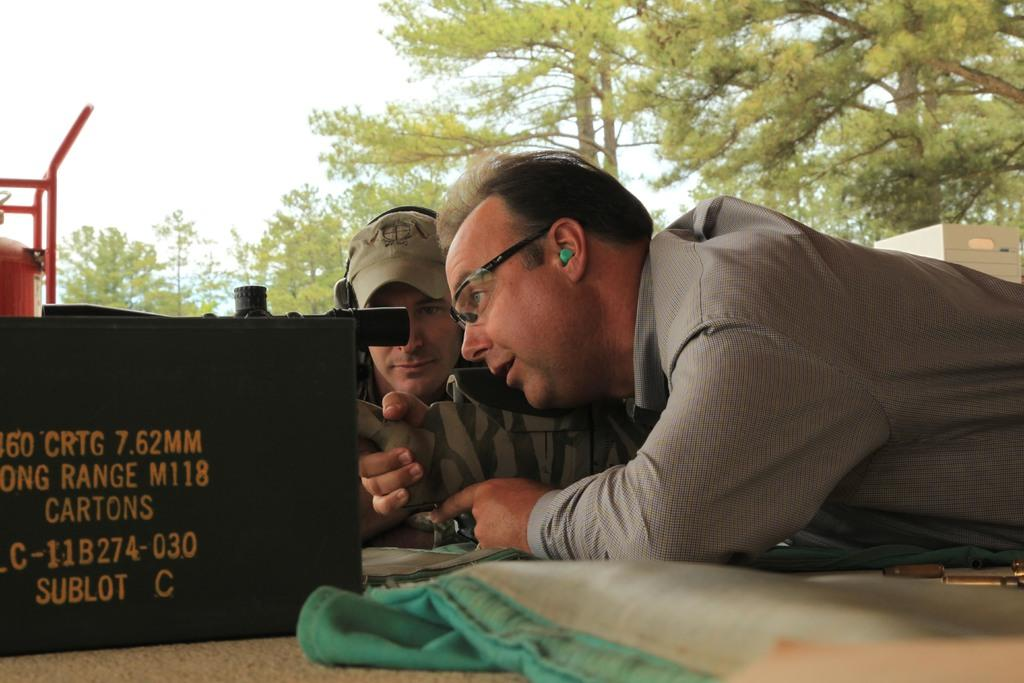How many people are present in the image? There are two persons in the image. What can be seen on the floor in the image? There are many objects on the floor in the image. What type of natural scenery is visible in the image? There are many trees in the image. What is visible in the background of the image? There is a sky visible in the image. What type of oven can be seen in the image? There is no oven present in the image. How many rings are visible on the trees in the image? There are no rings visible on the trees in the image; we can only see the trees themselves. 